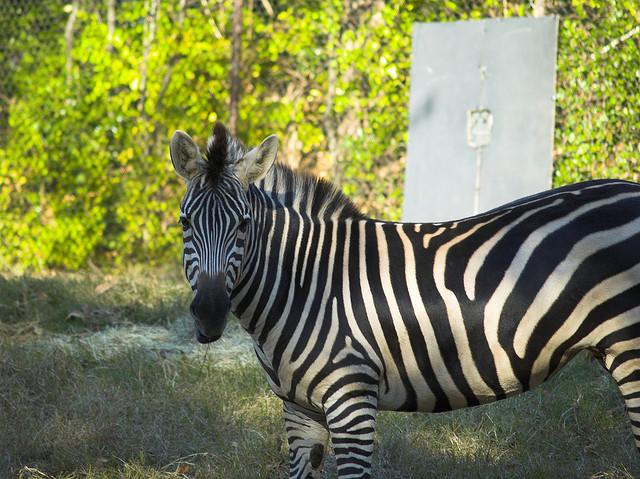How many animals are in the image?
Answer briefly. 1. How many zoo animals are there?
Give a very brief answer. 1. How many legs of the zebra can you see?
Quick response, please. 3. Are the zebras in a zoo?
Write a very short answer. Yes. Is that a door in the background?
Concise answer only. No. What animal is this?
Answer briefly. Zebra. 